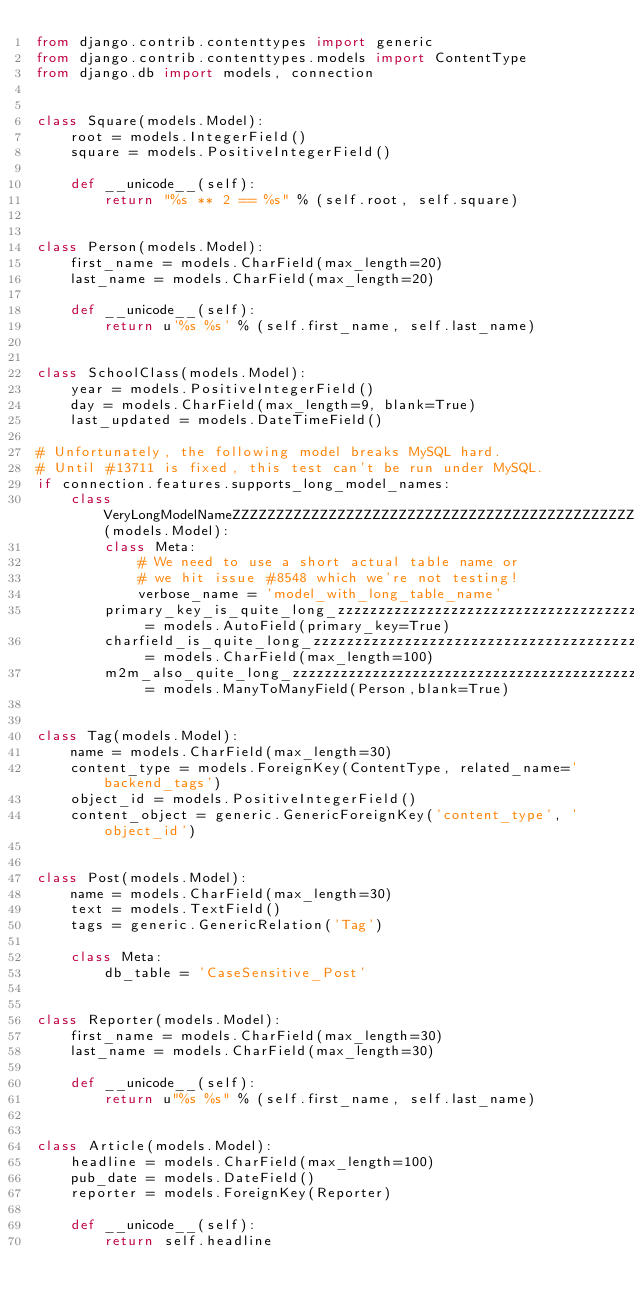<code> <loc_0><loc_0><loc_500><loc_500><_Python_>from django.contrib.contenttypes import generic
from django.contrib.contenttypes.models import ContentType
from django.db import models, connection


class Square(models.Model):
    root = models.IntegerField()
    square = models.PositiveIntegerField()

    def __unicode__(self):
        return "%s ** 2 == %s" % (self.root, self.square)


class Person(models.Model):
    first_name = models.CharField(max_length=20)
    last_name = models.CharField(max_length=20)

    def __unicode__(self):
        return u'%s %s' % (self.first_name, self.last_name)


class SchoolClass(models.Model):
    year = models.PositiveIntegerField()
    day = models.CharField(max_length=9, blank=True)
    last_updated = models.DateTimeField()

# Unfortunately, the following model breaks MySQL hard.
# Until #13711 is fixed, this test can't be run under MySQL.
if connection.features.supports_long_model_names:
    class VeryLongModelNameZZZZZZZZZZZZZZZZZZZZZZZZZZZZZZZZZZZZZZZZZZZZZZZZZZZZZ(models.Model):
        class Meta:
            # We need to use a short actual table name or
            # we hit issue #8548 which we're not testing!
            verbose_name = 'model_with_long_table_name'
        primary_key_is_quite_long_zzzzzzzzzzzzzzzzzzzzzzzzzzzzzzzzzzzzz = models.AutoField(primary_key=True)
        charfield_is_quite_long_zzzzzzzzzzzzzzzzzzzzzzzzzzzzzzzzzzzzzzz = models.CharField(max_length=100)
        m2m_also_quite_long_zzzzzzzzzzzzzzzzzzzzzzzzzzzzzzzzzzzzzzzzzzz = models.ManyToManyField(Person,blank=True)


class Tag(models.Model):
    name = models.CharField(max_length=30)
    content_type = models.ForeignKey(ContentType, related_name='backend_tags')
    object_id = models.PositiveIntegerField()
    content_object = generic.GenericForeignKey('content_type', 'object_id')


class Post(models.Model):
    name = models.CharField(max_length=30)
    text = models.TextField()
    tags = generic.GenericRelation('Tag')

    class Meta:
        db_table = 'CaseSensitive_Post'


class Reporter(models.Model):
    first_name = models.CharField(max_length=30)
    last_name = models.CharField(max_length=30)

    def __unicode__(self):
        return u"%s %s" % (self.first_name, self.last_name)


class Article(models.Model):
    headline = models.CharField(max_length=100)
    pub_date = models.DateField()
    reporter = models.ForeignKey(Reporter)

    def __unicode__(self):
        return self.headline
</code> 